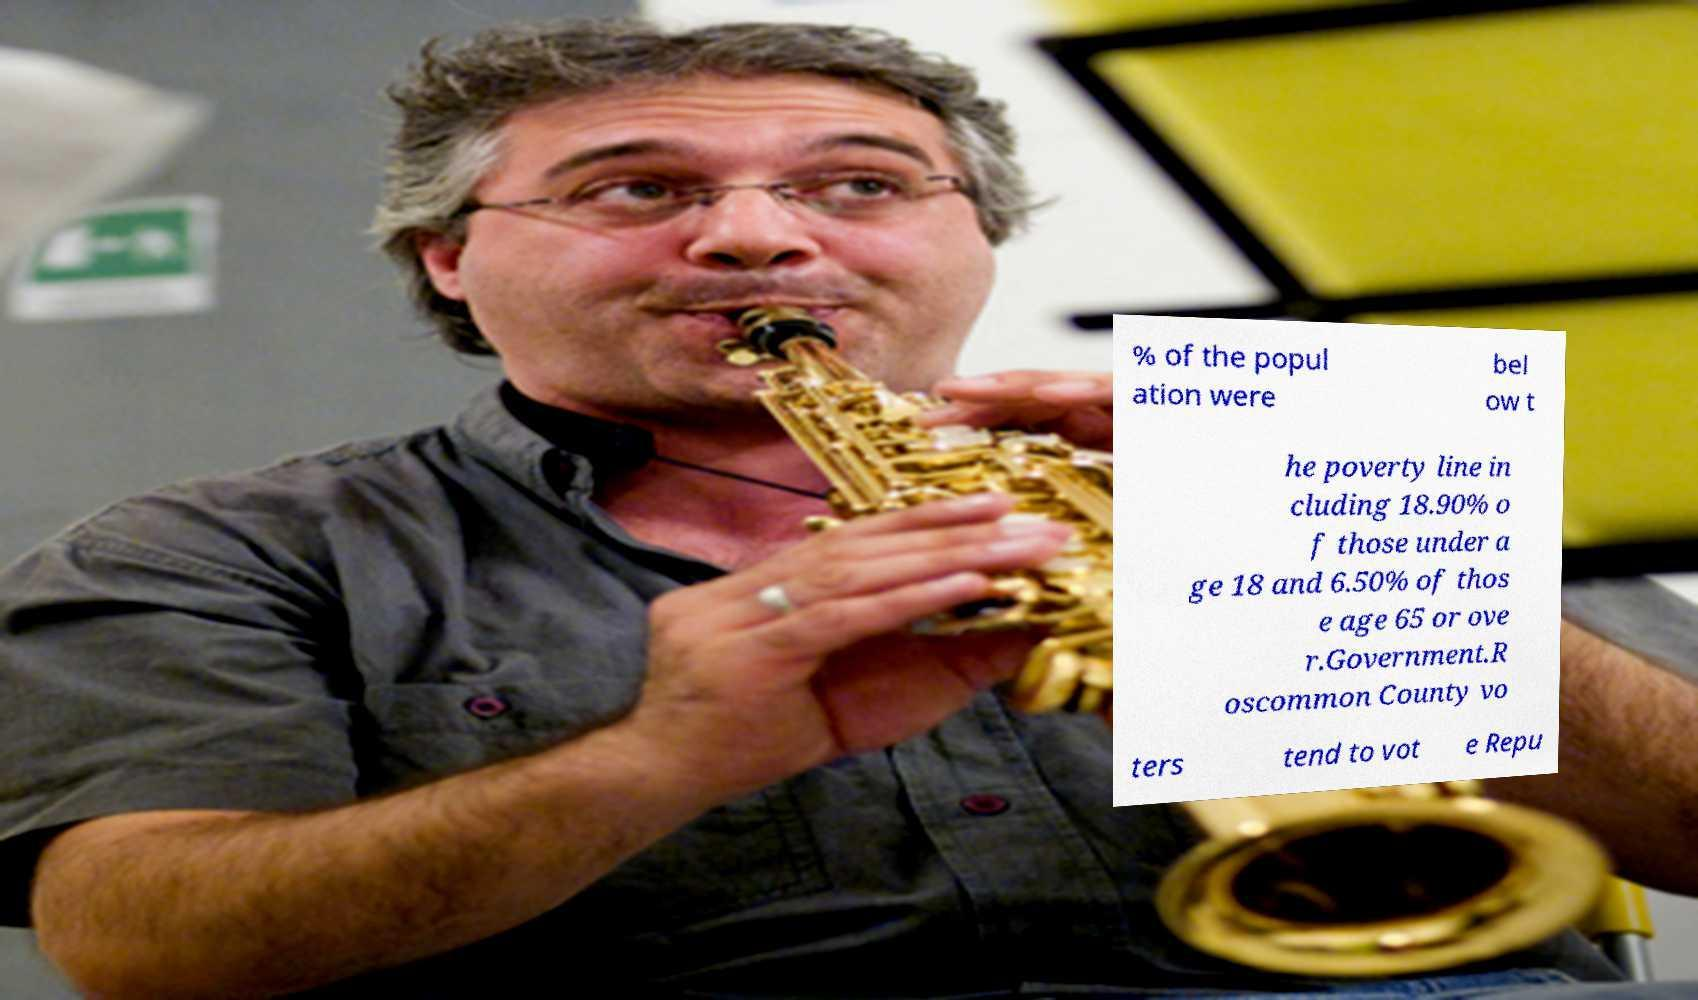Can you read and provide the text displayed in the image?This photo seems to have some interesting text. Can you extract and type it out for me? % of the popul ation were bel ow t he poverty line in cluding 18.90% o f those under a ge 18 and 6.50% of thos e age 65 or ove r.Government.R oscommon County vo ters tend to vot e Repu 